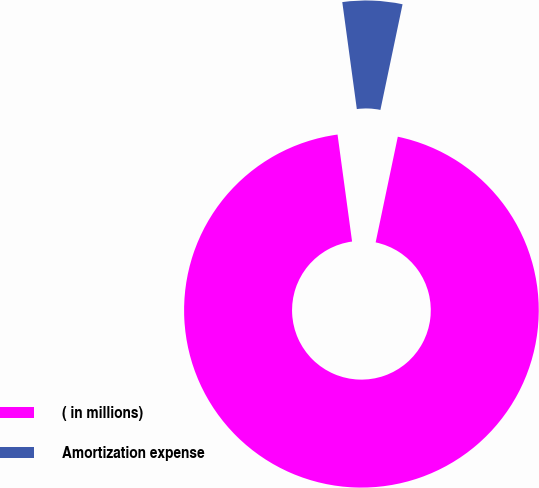<chart> <loc_0><loc_0><loc_500><loc_500><pie_chart><fcel>( in millions)<fcel>Amortization expense<nl><fcel>94.56%<fcel>5.44%<nl></chart> 